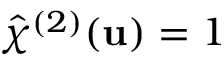<formula> <loc_0><loc_0><loc_500><loc_500>\hat { \chi } ^ { ( 2 ) } ( u ) = 1</formula> 